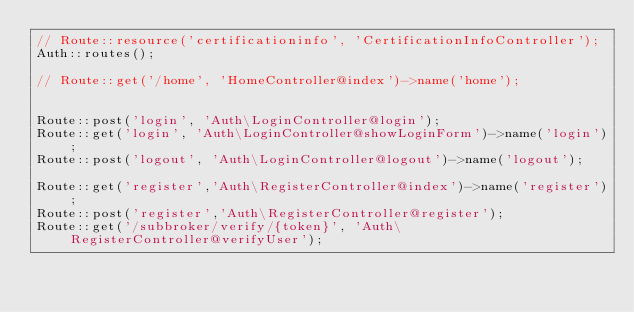<code> <loc_0><loc_0><loc_500><loc_500><_PHP_>// Route::resource('certificationinfo', 'CertificationInfoController');
Auth::routes();

// Route::get('/home', 'HomeController@index')->name('home');


Route::post('login', 'Auth\LoginController@login');
Route::get('login', 'Auth\LoginController@showLoginForm')->name('login');
Route::post('logout', 'Auth\LoginController@logout')->name('logout');

Route::get('register','Auth\RegisterController@index')->name('register');
Route::post('register','Auth\RegisterController@register');
Route::get('/subbroker/verify/{token}', 'Auth\RegisterController@verifyUser');
</code> 